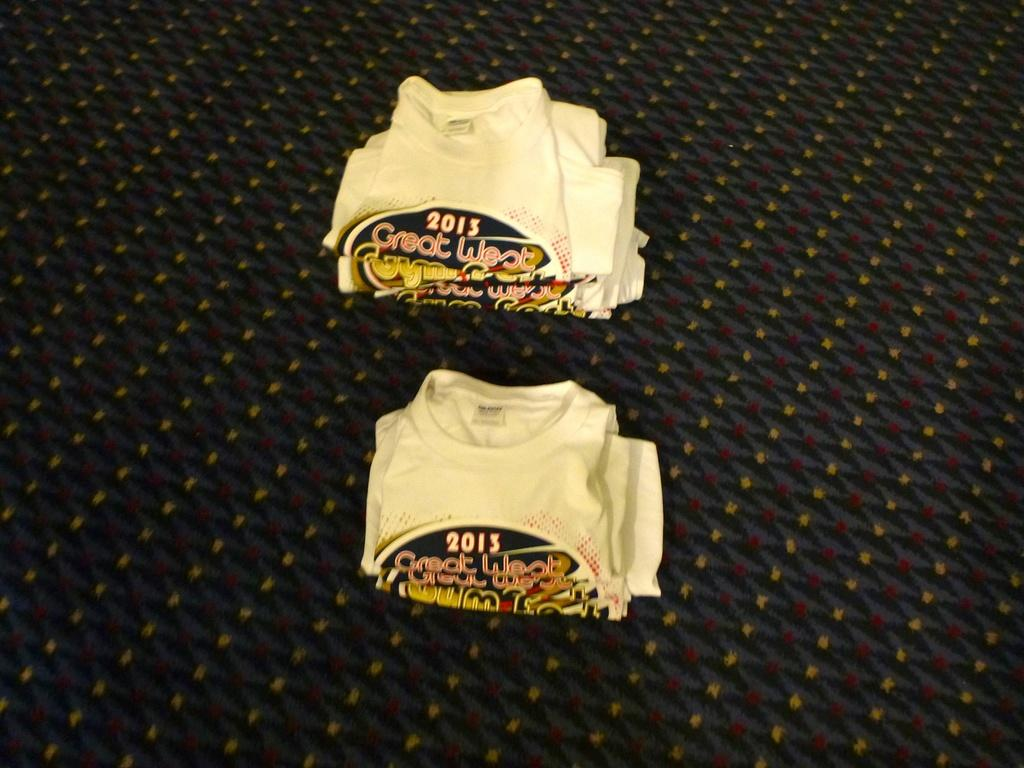<image>
Offer a succinct explanation of the picture presented. Two stacks of folded t-shirts from 2013 are sitting next to each other. 